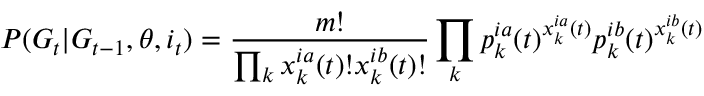<formula> <loc_0><loc_0><loc_500><loc_500>P ( G _ { t } | G _ { t - 1 } , \theta , i _ { t } ) = \frac { m ! } { \prod _ { k } x _ { k } ^ { i a } ( t ) ! x _ { k } ^ { i b } ( t ) ! } \prod _ { k } p _ { k } ^ { i a } ( t ) ^ { x _ { k } ^ { i a } ( t ) } p _ { k } ^ { i b } ( t ) ^ { x _ { k } ^ { i b } ( t ) }</formula> 